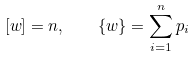<formula> <loc_0><loc_0><loc_500><loc_500>[ w ] = n , \quad \{ w \} = \sum _ { i = 1 } ^ { n } p _ { i }</formula> 